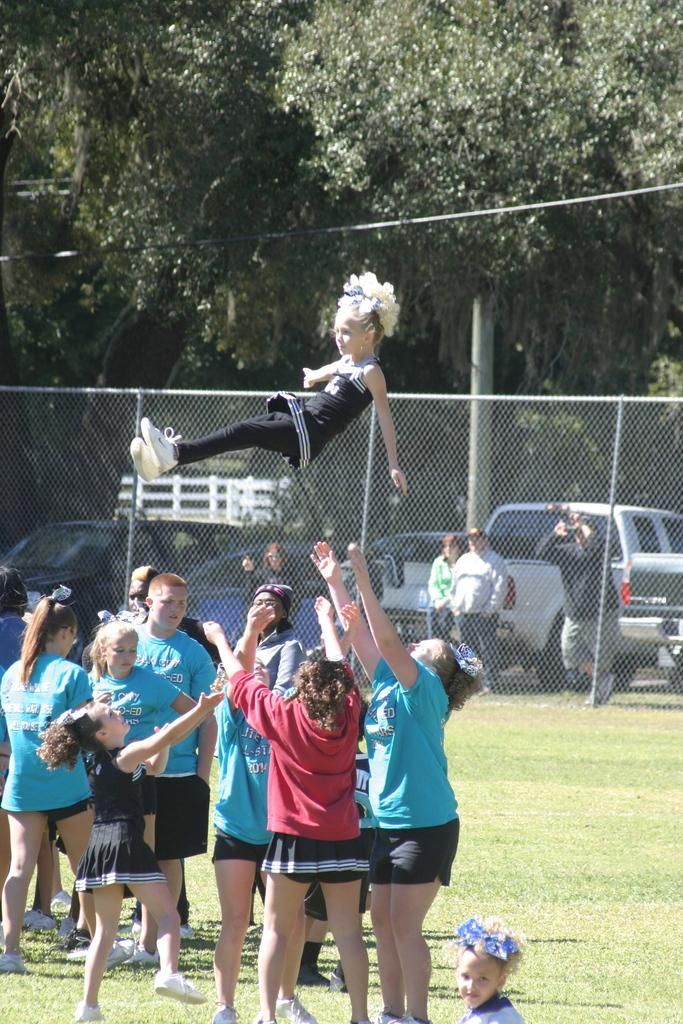What are the people in the image doing? There is a group of people standing on the ground in the image. What object is present in the image that is typically used for separating or dividing? There is a net in the image. What is the girl in the image doing? A girl is in the air in the image. What can be seen in the distance behind the people in the image? There are vehicles visible in the background of the image. What type of vegetation is present in the background of the image? Trees are present in the background of the image. What type of flowers can be seen growing on the net in the image? There are no flowers present in the image, and the net is not associated with any plant growth. 